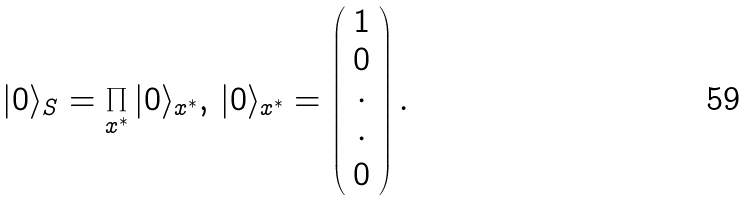<formula> <loc_0><loc_0><loc_500><loc_500>| 0 \rangle _ { S } = \prod _ { x ^ { \ast } } | 0 \rangle _ { x ^ { \ast } } , \, | 0 \rangle _ { x ^ { \ast } } = \left ( \begin{array} { c } 1 \\ 0 \\ \cdot \\ \cdot \\ 0 \end{array} \right ) .</formula> 